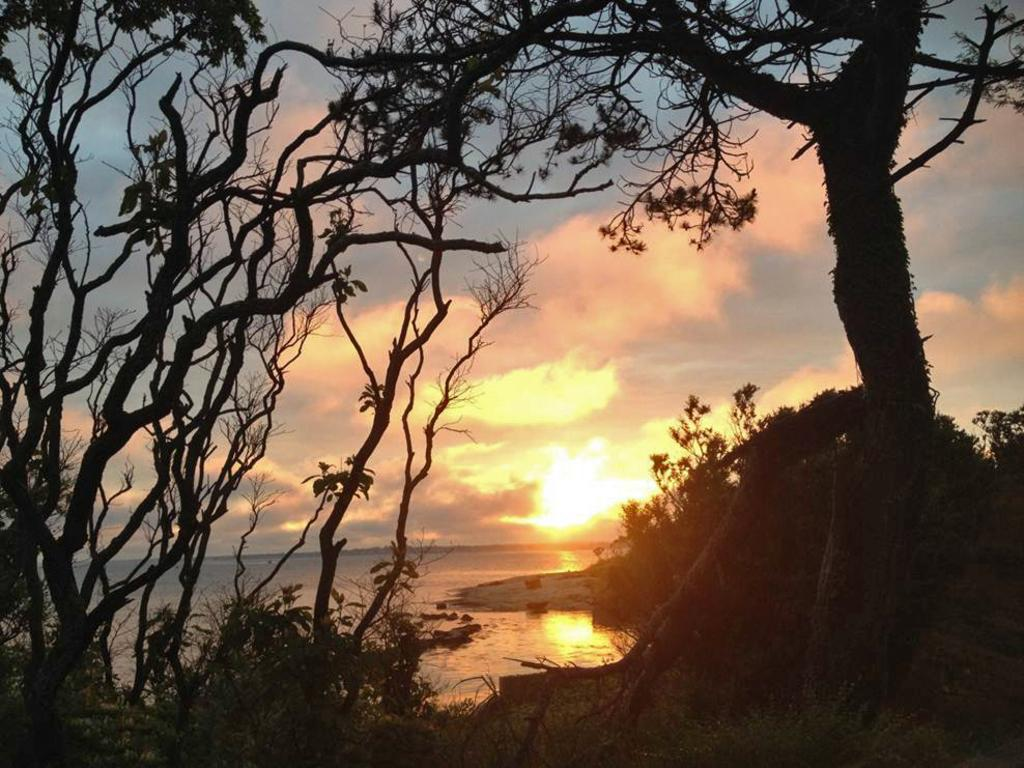What type of vegetation can be seen in the image? There are trees and plants in the image. What natural element is visible in the image? Water is visible in the image. What is visible in the background of the image? The sky is visible in the background of the image. What can be seen in the sky? There are clouds in the sky. Where is the kitten sitting in the image? There is no kitten present in the image. What type of furniture can be seen in the image? There is no furniture present in the image. 